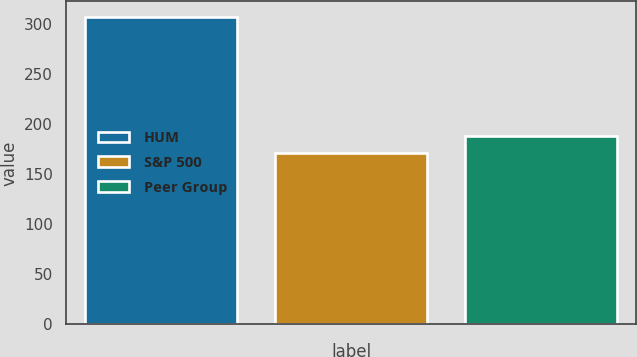Convert chart to OTSL. <chart><loc_0><loc_0><loc_500><loc_500><bar_chart><fcel>HUM<fcel>S&P 500<fcel>Peer Group<nl><fcel>307<fcel>171<fcel>188<nl></chart> 